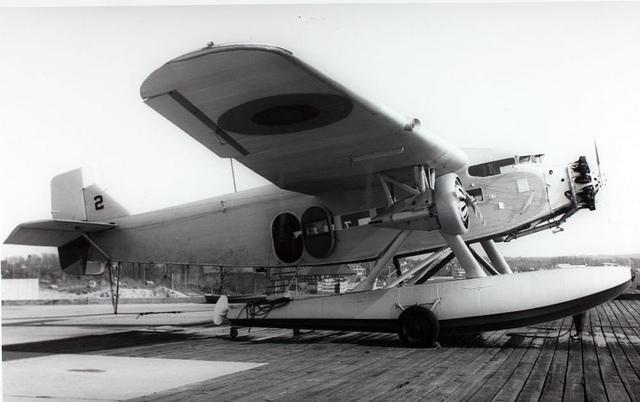Is this photo in color?
Keep it brief. No. What is on the bottom of the plane?
Give a very brief answer. Boat. Is the plane in the air?
Keep it brief. No. 